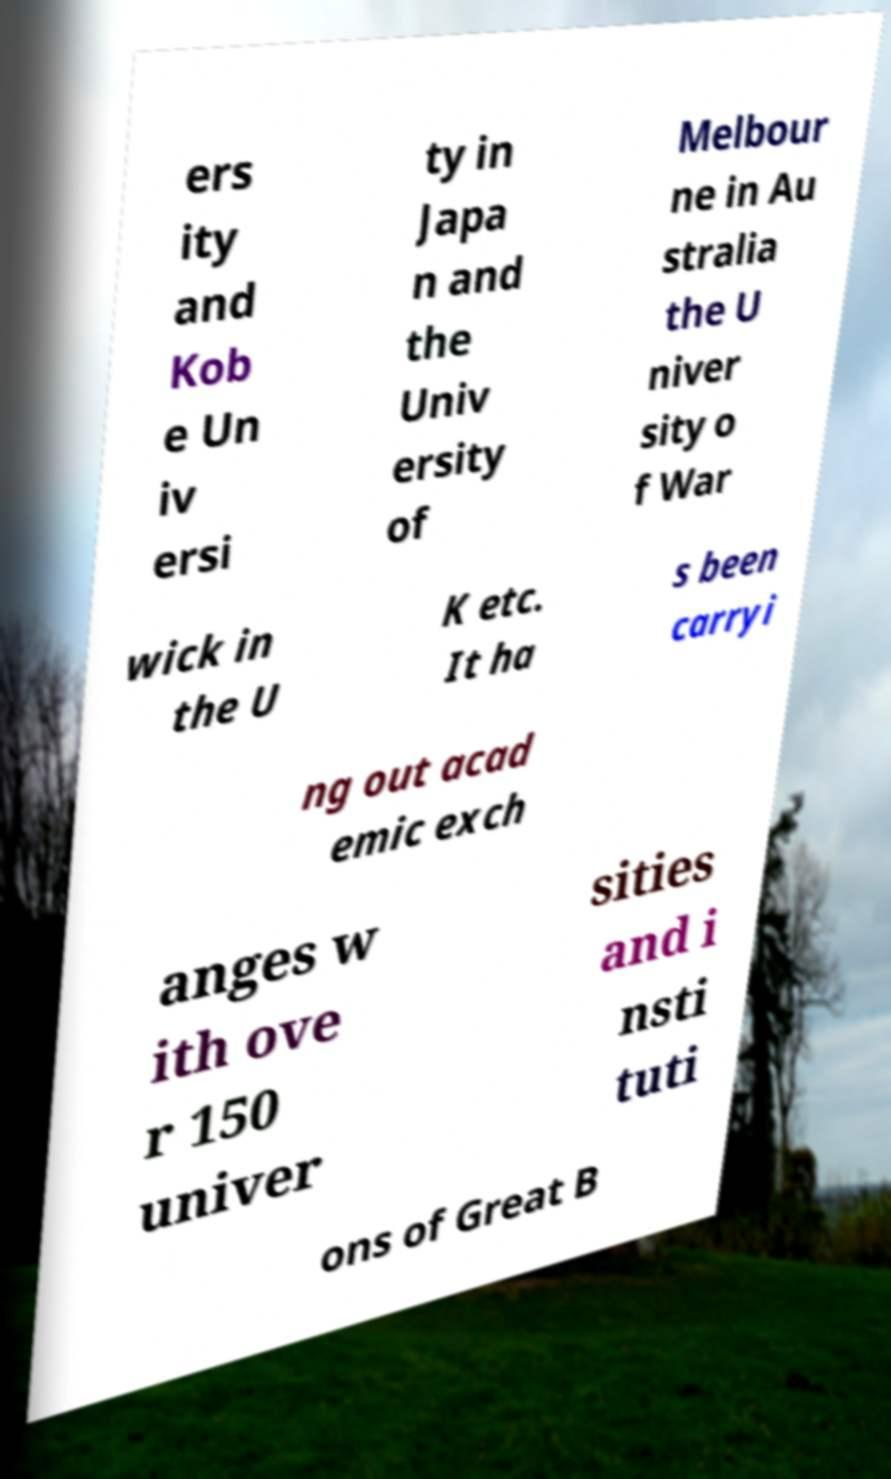Could you assist in decoding the text presented in this image and type it out clearly? ers ity and Kob e Un iv ersi ty in Japa n and the Univ ersity of Melbour ne in Au stralia the U niver sity o f War wick in the U K etc. It ha s been carryi ng out acad emic exch anges w ith ove r 150 univer sities and i nsti tuti ons of Great B 